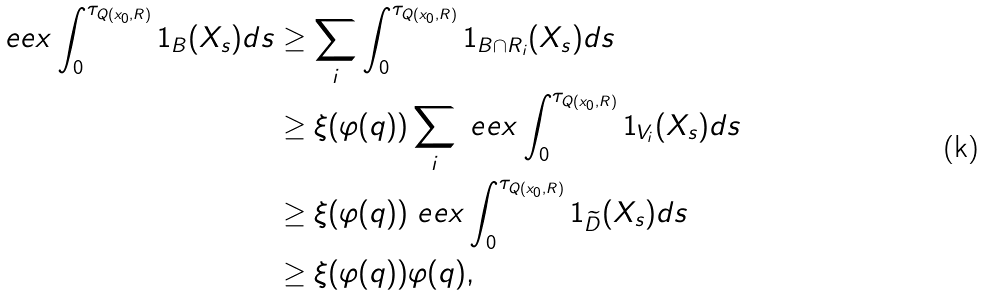<formula> <loc_0><loc_0><loc_500><loc_500>\ e e x \int _ { 0 } ^ { \tau _ { Q ( x _ { 0 } , R ) } } 1 _ { B } ( X _ { s } ) d s & \geq \sum _ { i } \int _ { 0 } ^ { \tau _ { Q ( x _ { 0 } , R ) } } 1 _ { B \cap R _ { i } } ( X _ { s } ) d s \\ & \geq \xi ( \varphi ( q ) ) \sum _ { i } \ e e x \int _ { 0 } ^ { \tau _ { Q ( x _ { 0 } , R ) } } 1 _ { V _ { i } } ( X _ { s } ) d s \\ & \geq \xi ( \varphi ( q ) ) \ e e x \int _ { 0 } ^ { \tau _ { Q ( x _ { 0 } , R ) } } 1 _ { \widetilde { D } } ( X _ { s } ) d s \\ & \geq \xi ( \varphi ( q ) ) \varphi ( q ) ,</formula> 